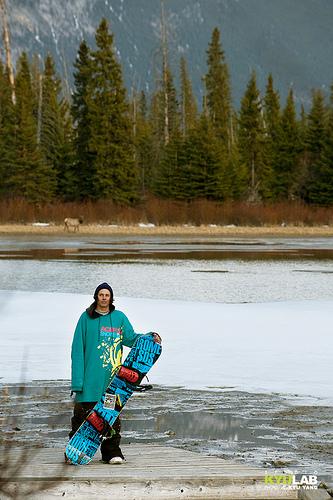Is this person wearing a hat?
Quick response, please. Yes. Is the water iced over?
Keep it brief. Yes. Is there snow?
Write a very short answer. Yes. 